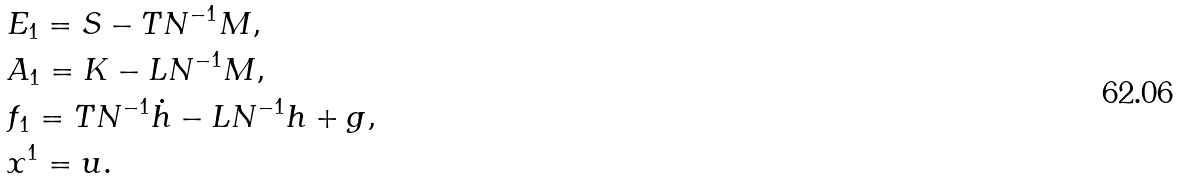<formula> <loc_0><loc_0><loc_500><loc_500>& E _ { 1 } = S - T N ^ { - 1 } M , \\ & A _ { 1 } = K - L N ^ { - 1 } M , \\ & f _ { 1 } = T N ^ { - 1 } \dot { h } - L N ^ { - 1 } h + g , \\ & x ^ { 1 } = u .</formula> 